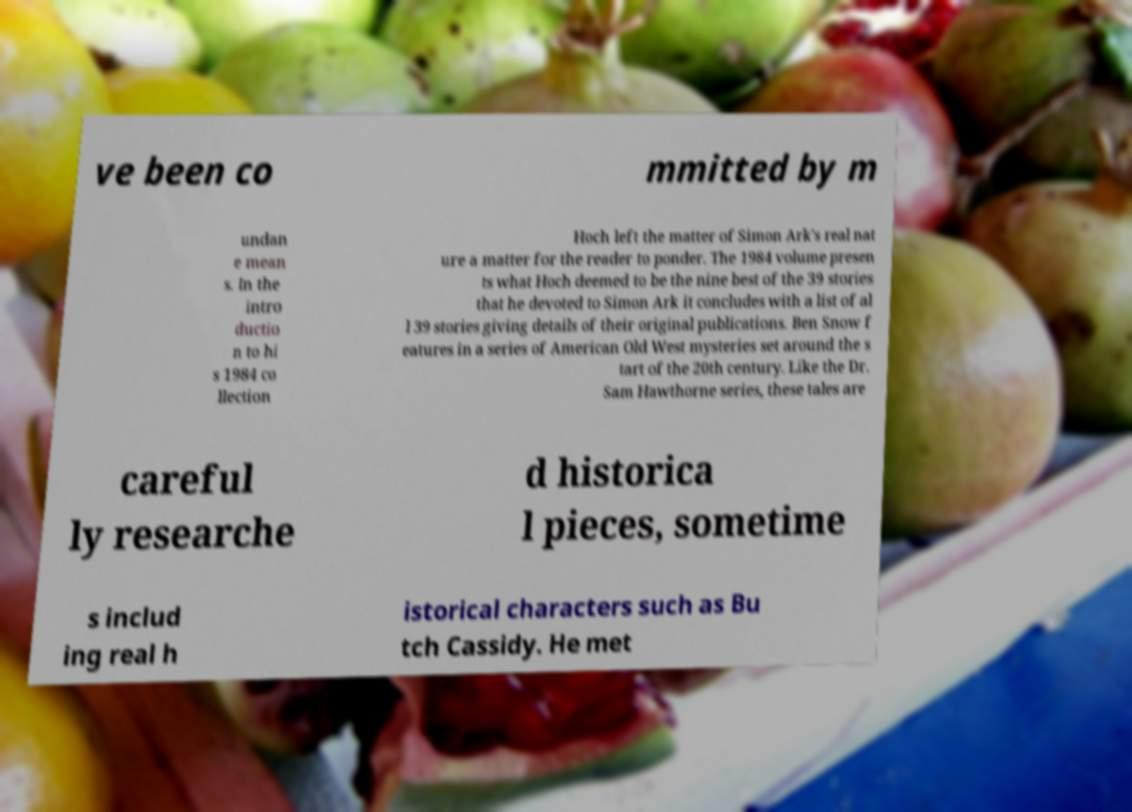I need the written content from this picture converted into text. Can you do that? ve been co mmitted by m undan e mean s. In the intro ductio n to hi s 1984 co llection Hoch left the matter of Simon Ark's real nat ure a matter for the reader to ponder. The 1984 volume presen ts what Hoch deemed to be the nine best of the 39 stories that he devoted to Simon Ark it concludes with a list of al l 39 stories giving details of their original publications. Ben Snow f eatures in a series of American Old West mysteries set around the s tart of the 20th century. Like the Dr. Sam Hawthorne series, these tales are careful ly researche d historica l pieces, sometime s includ ing real h istorical characters such as Bu tch Cassidy. He met 